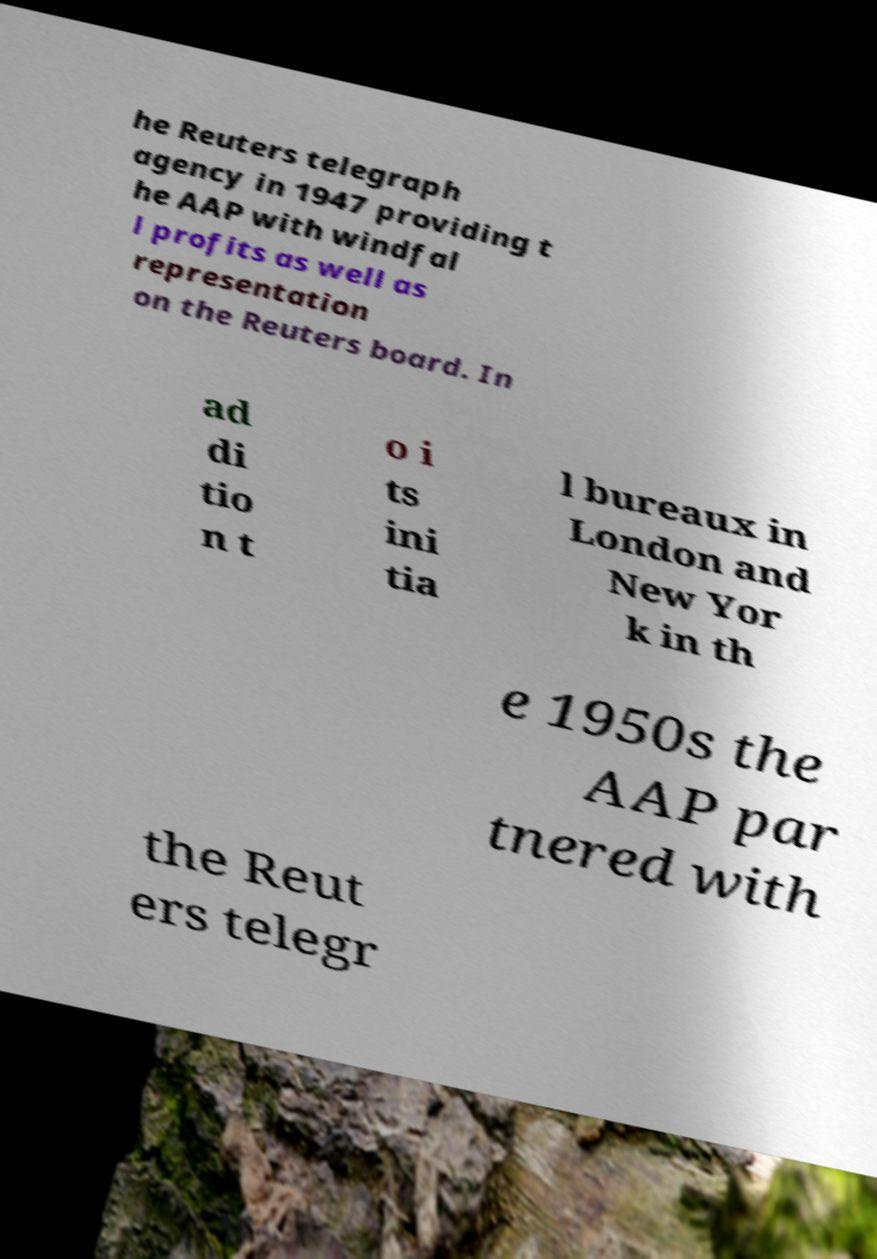What messages or text are displayed in this image? I need them in a readable, typed format. he Reuters telegraph agency in 1947 providing t he AAP with windfal l profits as well as representation on the Reuters board. In ad di tio n t o i ts ini tia l bureaux in London and New Yor k in th e 1950s the AAP par tnered with the Reut ers telegr 